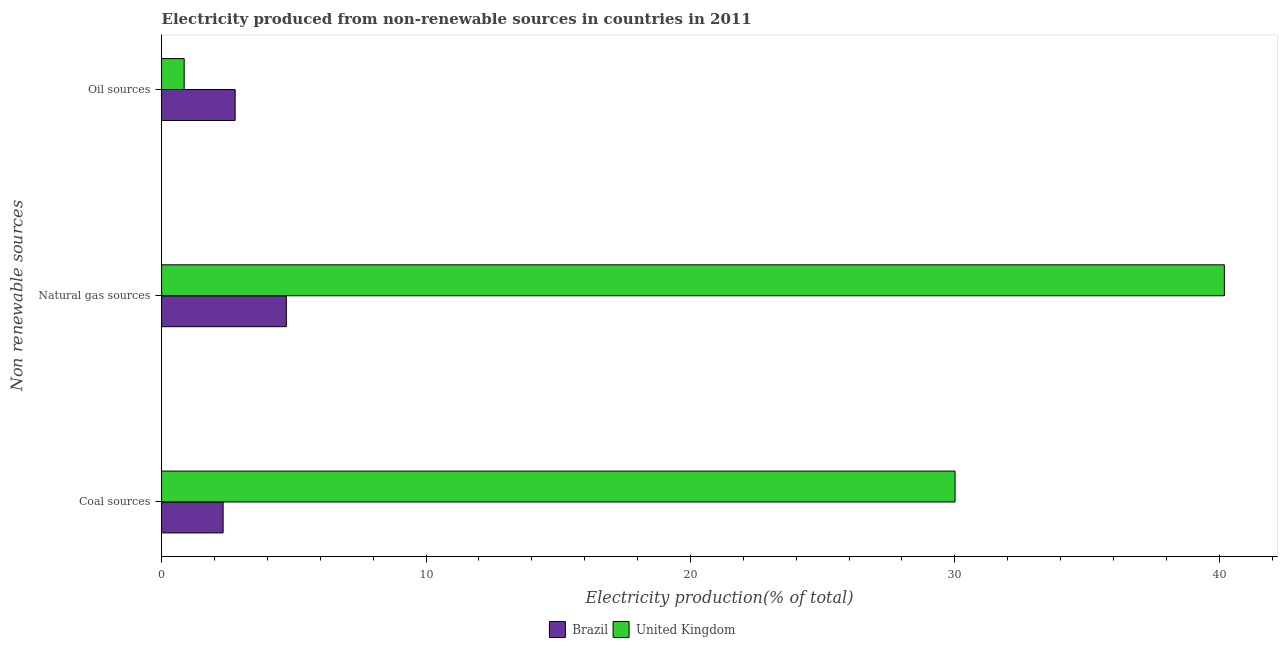Are the number of bars per tick equal to the number of legend labels?
Your answer should be compact. Yes. Are the number of bars on each tick of the Y-axis equal?
Provide a succinct answer. Yes. How many bars are there on the 2nd tick from the top?
Provide a short and direct response. 2. How many bars are there on the 3rd tick from the bottom?
Your answer should be compact. 2. What is the label of the 2nd group of bars from the top?
Your answer should be compact. Natural gas sources. What is the percentage of electricity produced by natural gas in Brazil?
Make the answer very short. 4.72. Across all countries, what is the maximum percentage of electricity produced by oil sources?
Your answer should be very brief. 2.78. Across all countries, what is the minimum percentage of electricity produced by oil sources?
Offer a very short reply. 0.86. In which country was the percentage of electricity produced by coal maximum?
Give a very brief answer. United Kingdom. In which country was the percentage of electricity produced by coal minimum?
Provide a succinct answer. Brazil. What is the total percentage of electricity produced by coal in the graph?
Give a very brief answer. 32.34. What is the difference between the percentage of electricity produced by coal in Brazil and that in United Kingdom?
Offer a terse response. -27.68. What is the difference between the percentage of electricity produced by oil sources in United Kingdom and the percentage of electricity produced by coal in Brazil?
Make the answer very short. -1.47. What is the average percentage of electricity produced by oil sources per country?
Provide a succinct answer. 1.82. What is the difference between the percentage of electricity produced by oil sources and percentage of electricity produced by coal in Brazil?
Offer a terse response. 0.45. In how many countries, is the percentage of electricity produced by oil sources greater than 28 %?
Give a very brief answer. 0. What is the ratio of the percentage of electricity produced by coal in Brazil to that in United Kingdom?
Provide a succinct answer. 0.08. What is the difference between the highest and the second highest percentage of electricity produced by coal?
Provide a short and direct response. 27.68. What is the difference between the highest and the lowest percentage of electricity produced by natural gas?
Your response must be concise. 35.47. Is the sum of the percentage of electricity produced by natural gas in United Kingdom and Brazil greater than the maximum percentage of electricity produced by oil sources across all countries?
Your response must be concise. Yes. What does the 1st bar from the top in Natural gas sources represents?
Provide a succinct answer. United Kingdom. Is it the case that in every country, the sum of the percentage of electricity produced by coal and percentage of electricity produced by natural gas is greater than the percentage of electricity produced by oil sources?
Make the answer very short. Yes. How many countries are there in the graph?
Offer a very short reply. 2. Does the graph contain grids?
Give a very brief answer. No. What is the title of the graph?
Your response must be concise. Electricity produced from non-renewable sources in countries in 2011. What is the label or title of the X-axis?
Your response must be concise. Electricity production(% of total). What is the label or title of the Y-axis?
Ensure brevity in your answer.  Non renewable sources. What is the Electricity production(% of total) in Brazil in Coal sources?
Your answer should be compact. 2.33. What is the Electricity production(% of total) of United Kingdom in Coal sources?
Your answer should be very brief. 30.01. What is the Electricity production(% of total) of Brazil in Natural gas sources?
Make the answer very short. 4.72. What is the Electricity production(% of total) in United Kingdom in Natural gas sources?
Ensure brevity in your answer.  40.19. What is the Electricity production(% of total) of Brazil in Oil sources?
Offer a very short reply. 2.78. What is the Electricity production(% of total) of United Kingdom in Oil sources?
Ensure brevity in your answer.  0.86. Across all Non renewable sources, what is the maximum Electricity production(% of total) in Brazil?
Your answer should be compact. 4.72. Across all Non renewable sources, what is the maximum Electricity production(% of total) in United Kingdom?
Provide a succinct answer. 40.19. Across all Non renewable sources, what is the minimum Electricity production(% of total) of Brazil?
Provide a short and direct response. 2.33. Across all Non renewable sources, what is the minimum Electricity production(% of total) in United Kingdom?
Give a very brief answer. 0.86. What is the total Electricity production(% of total) of Brazil in the graph?
Your answer should be compact. 9.83. What is the total Electricity production(% of total) in United Kingdom in the graph?
Keep it short and to the point. 71.06. What is the difference between the Electricity production(% of total) of Brazil in Coal sources and that in Natural gas sources?
Your answer should be compact. -2.39. What is the difference between the Electricity production(% of total) of United Kingdom in Coal sources and that in Natural gas sources?
Your answer should be very brief. -10.18. What is the difference between the Electricity production(% of total) in Brazil in Coal sources and that in Oil sources?
Make the answer very short. -0.45. What is the difference between the Electricity production(% of total) in United Kingdom in Coal sources and that in Oil sources?
Your answer should be very brief. 29.15. What is the difference between the Electricity production(% of total) in Brazil in Natural gas sources and that in Oil sources?
Provide a succinct answer. 1.94. What is the difference between the Electricity production(% of total) in United Kingdom in Natural gas sources and that in Oil sources?
Give a very brief answer. 39.34. What is the difference between the Electricity production(% of total) in Brazil in Coal sources and the Electricity production(% of total) in United Kingdom in Natural gas sources?
Ensure brevity in your answer.  -37.86. What is the difference between the Electricity production(% of total) of Brazil in Coal sources and the Electricity production(% of total) of United Kingdom in Oil sources?
Make the answer very short. 1.47. What is the difference between the Electricity production(% of total) in Brazil in Natural gas sources and the Electricity production(% of total) in United Kingdom in Oil sources?
Ensure brevity in your answer.  3.86. What is the average Electricity production(% of total) of Brazil per Non renewable sources?
Provide a succinct answer. 3.28. What is the average Electricity production(% of total) in United Kingdom per Non renewable sources?
Provide a succinct answer. 23.69. What is the difference between the Electricity production(% of total) of Brazil and Electricity production(% of total) of United Kingdom in Coal sources?
Your answer should be very brief. -27.68. What is the difference between the Electricity production(% of total) in Brazil and Electricity production(% of total) in United Kingdom in Natural gas sources?
Ensure brevity in your answer.  -35.47. What is the difference between the Electricity production(% of total) of Brazil and Electricity production(% of total) of United Kingdom in Oil sources?
Your answer should be very brief. 1.93. What is the ratio of the Electricity production(% of total) in Brazil in Coal sources to that in Natural gas sources?
Ensure brevity in your answer.  0.49. What is the ratio of the Electricity production(% of total) of United Kingdom in Coal sources to that in Natural gas sources?
Your response must be concise. 0.75. What is the ratio of the Electricity production(% of total) in Brazil in Coal sources to that in Oil sources?
Your response must be concise. 0.84. What is the ratio of the Electricity production(% of total) in United Kingdom in Coal sources to that in Oil sources?
Provide a succinct answer. 35.1. What is the ratio of the Electricity production(% of total) in Brazil in Natural gas sources to that in Oil sources?
Offer a terse response. 1.7. What is the ratio of the Electricity production(% of total) in United Kingdom in Natural gas sources to that in Oil sources?
Your response must be concise. 47.01. What is the difference between the highest and the second highest Electricity production(% of total) in Brazil?
Your response must be concise. 1.94. What is the difference between the highest and the second highest Electricity production(% of total) in United Kingdom?
Offer a terse response. 10.18. What is the difference between the highest and the lowest Electricity production(% of total) of Brazil?
Give a very brief answer. 2.39. What is the difference between the highest and the lowest Electricity production(% of total) of United Kingdom?
Your answer should be compact. 39.34. 